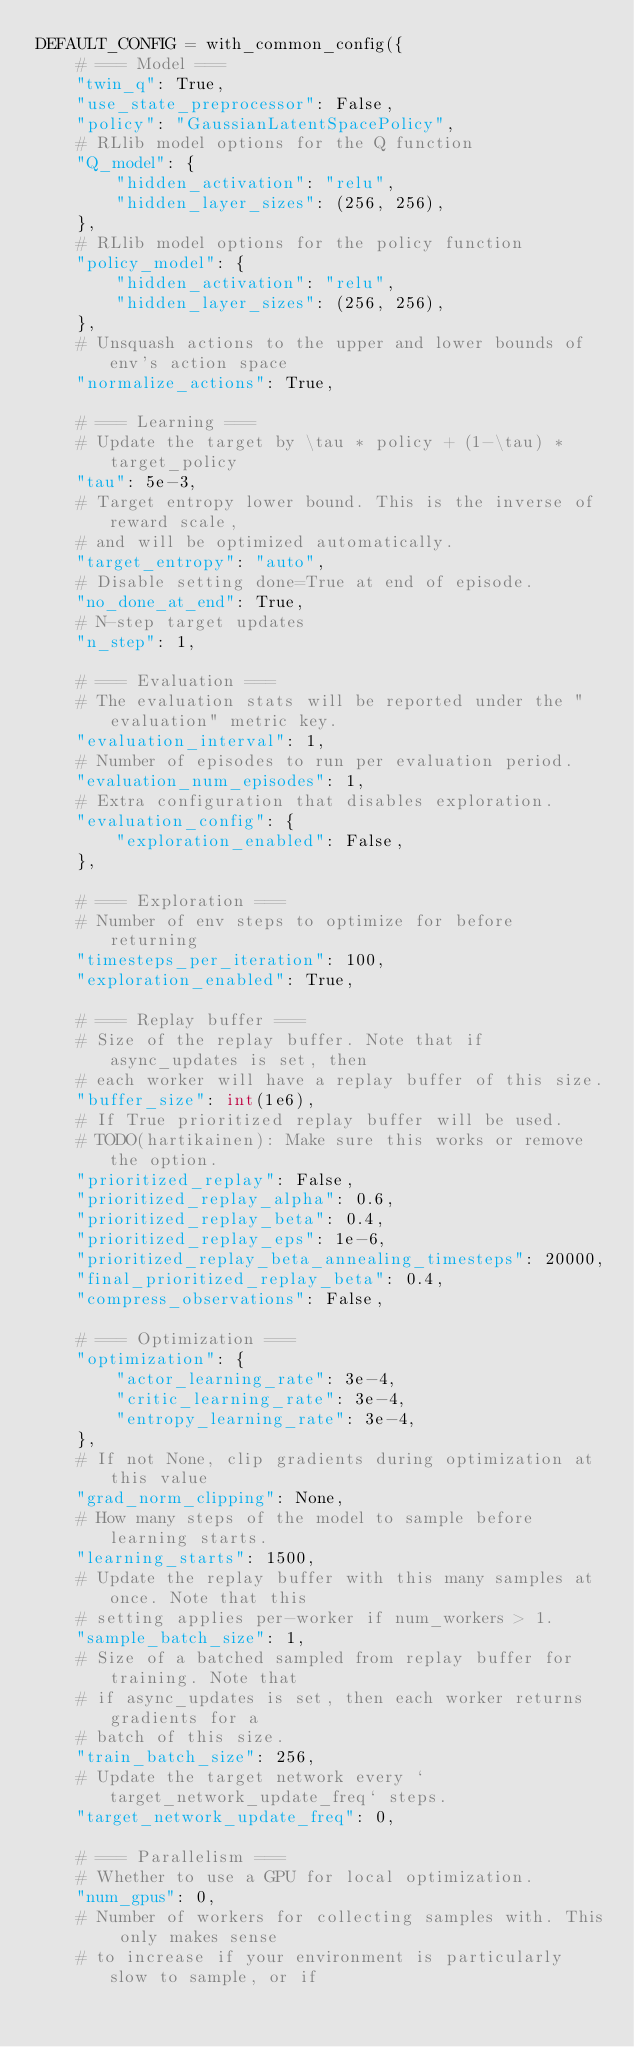<code> <loc_0><loc_0><loc_500><loc_500><_Python_>DEFAULT_CONFIG = with_common_config({
    # === Model ===
    "twin_q": True,
    "use_state_preprocessor": False,
    "policy": "GaussianLatentSpacePolicy",
    # RLlib model options for the Q function
    "Q_model": {
        "hidden_activation": "relu",
        "hidden_layer_sizes": (256, 256),
    },
    # RLlib model options for the policy function
    "policy_model": {
        "hidden_activation": "relu",
        "hidden_layer_sizes": (256, 256),
    },
    # Unsquash actions to the upper and lower bounds of env's action space
    "normalize_actions": True,

    # === Learning ===
    # Update the target by \tau * policy + (1-\tau) * target_policy
    "tau": 5e-3,
    # Target entropy lower bound. This is the inverse of reward scale,
    # and will be optimized automatically.
    "target_entropy": "auto",
    # Disable setting done=True at end of episode.
    "no_done_at_end": True,
    # N-step target updates
    "n_step": 1,

    # === Evaluation ===
    # The evaluation stats will be reported under the "evaluation" metric key.
    "evaluation_interval": 1,
    # Number of episodes to run per evaluation period.
    "evaluation_num_episodes": 1,
    # Extra configuration that disables exploration.
    "evaluation_config": {
        "exploration_enabled": False,
    },

    # === Exploration ===
    # Number of env steps to optimize for before returning
    "timesteps_per_iteration": 100,
    "exploration_enabled": True,

    # === Replay buffer ===
    # Size of the replay buffer. Note that if async_updates is set, then
    # each worker will have a replay buffer of this size.
    "buffer_size": int(1e6),
    # If True prioritized replay buffer will be used.
    # TODO(hartikainen): Make sure this works or remove the option.
    "prioritized_replay": False,
    "prioritized_replay_alpha": 0.6,
    "prioritized_replay_beta": 0.4,
    "prioritized_replay_eps": 1e-6,
    "prioritized_replay_beta_annealing_timesteps": 20000,
    "final_prioritized_replay_beta": 0.4,
    "compress_observations": False,

    # === Optimization ===
    "optimization": {
        "actor_learning_rate": 3e-4,
        "critic_learning_rate": 3e-4,
        "entropy_learning_rate": 3e-4,
    },
    # If not None, clip gradients during optimization at this value
    "grad_norm_clipping": None,
    # How many steps of the model to sample before learning starts.
    "learning_starts": 1500,
    # Update the replay buffer with this many samples at once. Note that this
    # setting applies per-worker if num_workers > 1.
    "sample_batch_size": 1,
    # Size of a batched sampled from replay buffer for training. Note that
    # if async_updates is set, then each worker returns gradients for a
    # batch of this size.
    "train_batch_size": 256,
    # Update the target network every `target_network_update_freq` steps.
    "target_network_update_freq": 0,

    # === Parallelism ===
    # Whether to use a GPU for local optimization.
    "num_gpus": 0,
    # Number of workers for collecting samples with. This only makes sense
    # to increase if your environment is particularly slow to sample, or if</code> 